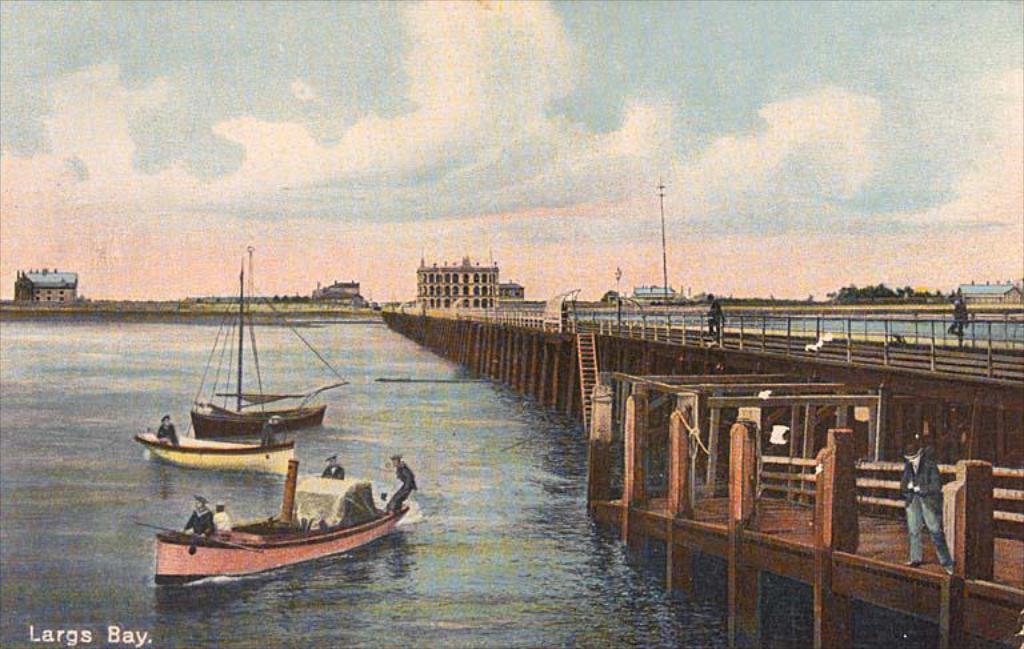Could you give a brief overview of what you see in this image? In this image on the right side, I can see some people are standing on the bridge. On the left side I can see some boats in the water. In the background, I can see the buildings and clouds in the sky. 